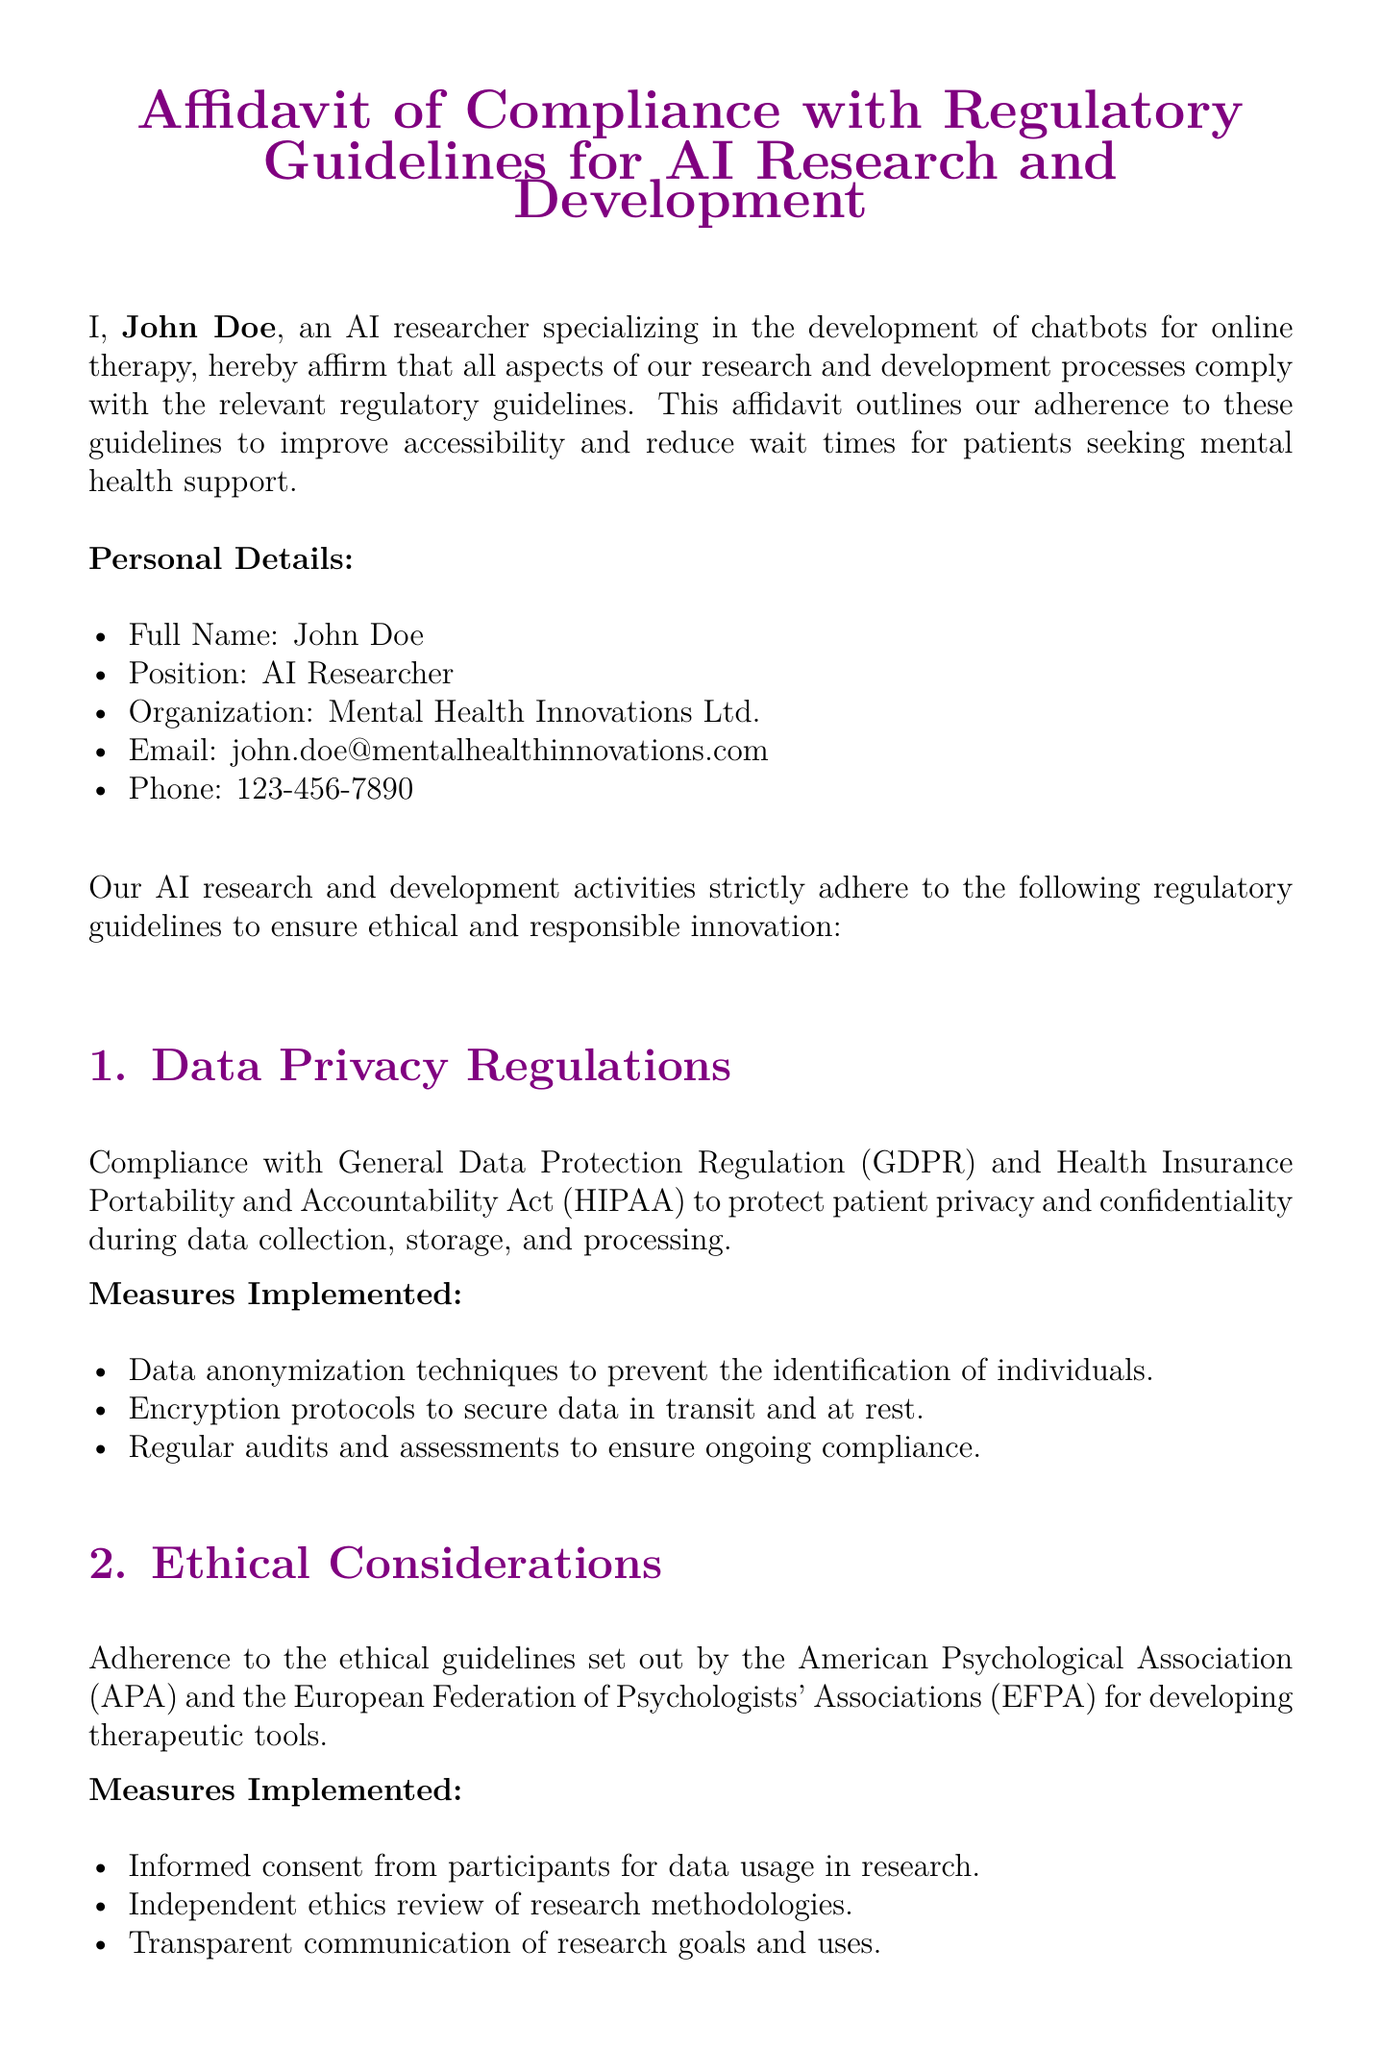What is the full name of the affiant? The full name of the affiant is presented in the document, which is John Doe.
Answer: John Doe What is the organization of the affiant? The organization is listed in the personal details section, which is Mental Health Innovations Ltd.
Answer: Mental Health Innovations Ltd Which regulatory guideline does the affidavit comply with regarding data privacy? The document mentions compliance with both GDPR and HIPAA regarding data privacy.
Answer: GDPR and HIPAA What are the encryption protocols used for? The document states that the encryption protocols are used to secure data in transit and at rest.
Answer: Secure data in transit and at rest What measures ensure informed consent from research participants? The document specifies that informed consent is obtained from participants for data usage in research as part of ethical considerations.
Answer: Informed consent What is one of the safety standards conformed to by the chatbot solutions? The affidavit mentions conformance with standards set by the FDA for software as a medical device.
Answer: FDA When was the affidavit signed? The affidavit indicates the date of signing at the end of the document, which is October 1, 2023.
Answer: October 1, 2023 What measures are taken for post-market surveillance? The document states that post-market surveillance is conducted to monitor and address any safety concerns.
Answer: Monitor and address safety concerns Which ethical guideline is adhered to according to the affidavit? The document refers to the ethical guidelines set out by the American Psychological Association (APA).
Answer: American Psychological Association (APA) 